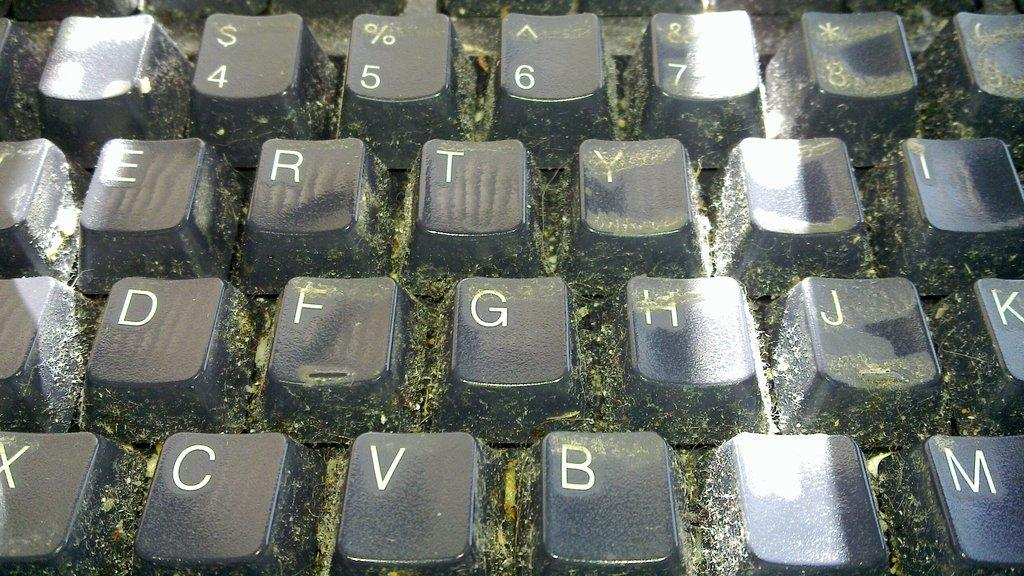<image>
Give a short and clear explanation of the subsequent image. A very dirty and moldy keyboard is shown  with the letter G in the center. 